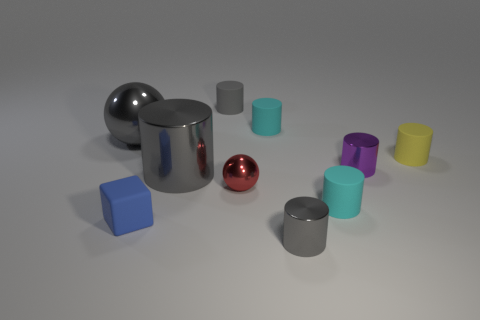There is a large cylinder; is its color the same as the metal sphere that is behind the tiny red metal thing?
Keep it short and to the point. Yes. What size is the metallic ball that is the same color as the large metal cylinder?
Make the answer very short. Large. What is the material of the tiny yellow thing?
Provide a succinct answer. Rubber. Is the color of the big cylinder the same as the big sphere?
Your response must be concise. Yes. Are there fewer matte things left of the small blue thing than small cubes?
Your response must be concise. Yes. The small rubber cylinder in front of the tiny purple cylinder is what color?
Keep it short and to the point. Cyan. What shape is the tiny yellow rubber object?
Provide a short and direct response. Cylinder. There is a cyan cylinder that is right of the small gray object on the right side of the gray matte thing; are there any matte things in front of it?
Your response must be concise. Yes. There is a tiny rubber thing that is to the right of the metal cylinder that is right of the small cyan cylinder in front of the tiny purple thing; what is its color?
Ensure brevity in your answer.  Yellow. There is another large object that is the same shape as the purple metal object; what is its material?
Provide a succinct answer. Metal. 